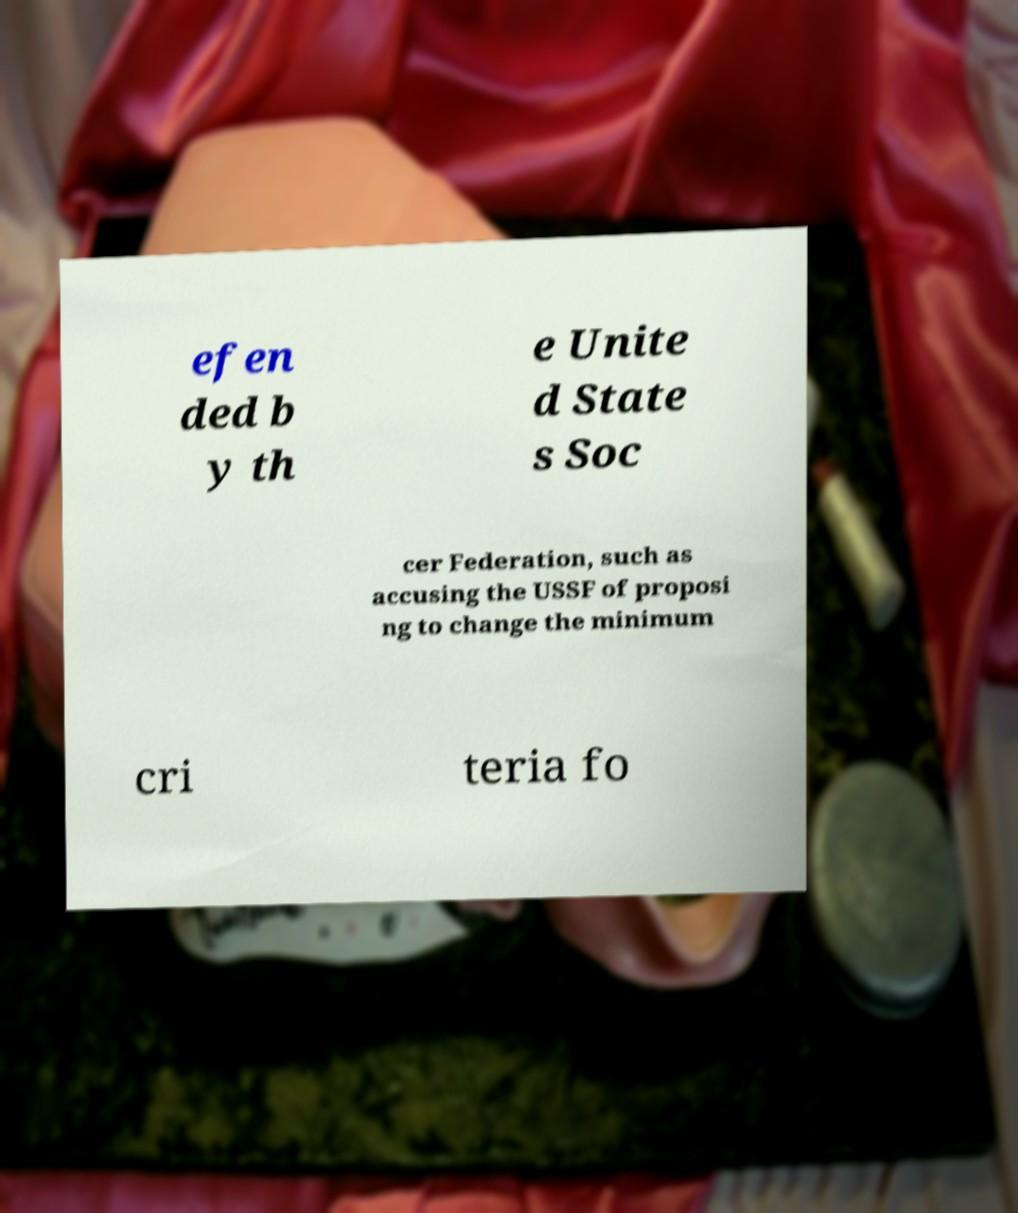Please read and relay the text visible in this image. What does it say? efen ded b y th e Unite d State s Soc cer Federation, such as accusing the USSF of proposi ng to change the minimum cri teria fo 